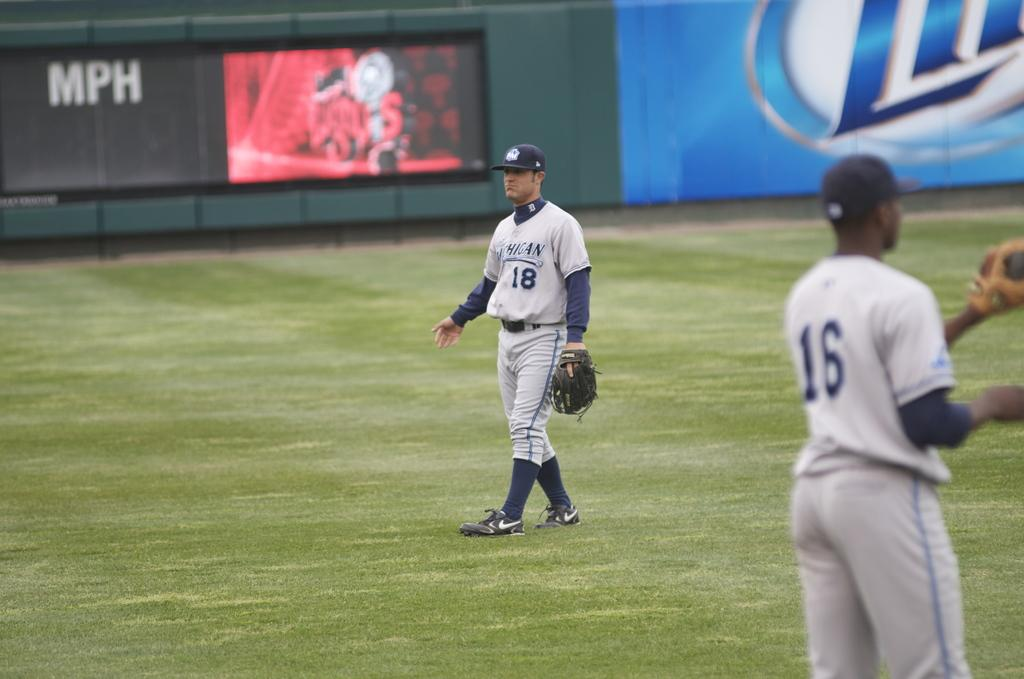<image>
Relay a brief, clear account of the picture shown. A baseball player with a jersey that says Michigan and has the number eighteen. 